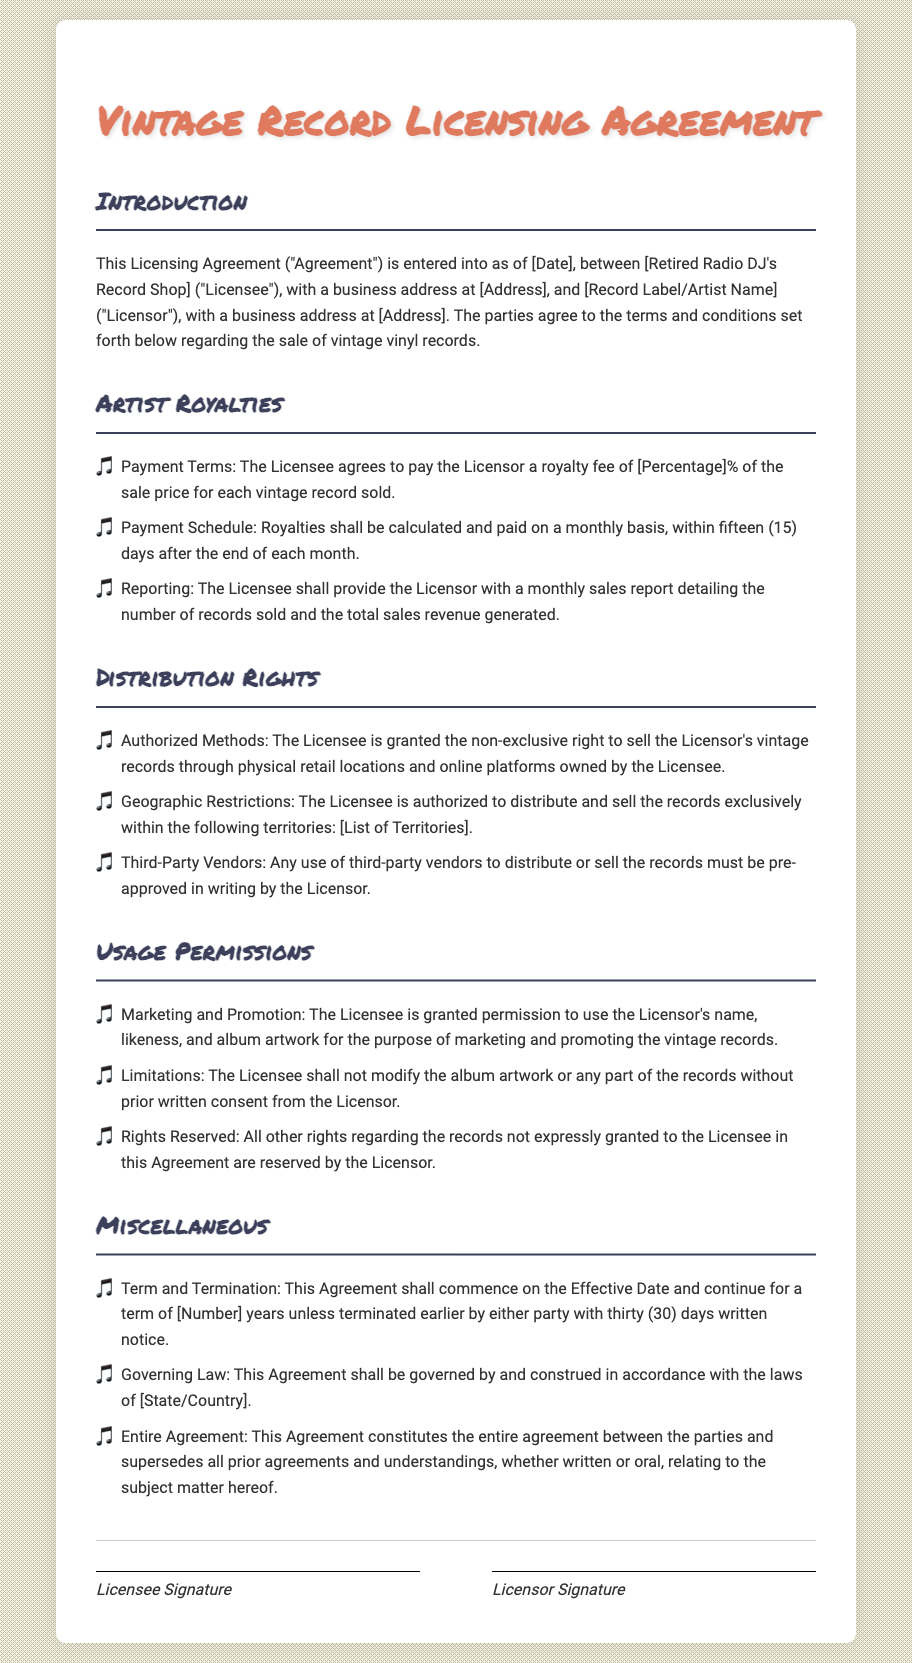What is the effective date of the Agreement? The effective date is marked as [Date], which will be filled in the actual document.
Answer: [Date] What percentage of sales does the Licensee pay as royalty? The royalty fee is specified as [Percentage]%, which will be defined in the actual agreement.
Answer: [Percentage]% How often are royalties calculated and paid? Royalties are to be calculated and paid on a monthly basis, as stated in the document.
Answer: Monthly What must be included in the monthly sales report? The Licensee must detail the number of records sold and the total sales revenue generated in the report.
Answer: Number of records sold and total sales revenue Within which locations can the Licensee sell the records? The document states that the Licensee can sell the records through physical retail locations and online platforms owned by the Licensee.
Answer: Physical retail locations and online platforms What is the minimum notice period for terminating the Agreement? The notice period required for termination of the Agreement is thirty (30) days, as outlined in the document.
Answer: Thirty (30) days What is reserved by the Licensor in this Agreement? All other rights regarding the records not expressly granted to the Licensee are reserved by the Licensor.
Answer: All other rights 